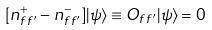<formula> <loc_0><loc_0><loc_500><loc_500>[ { n } ^ { + } _ { f \, f ^ { \prime } } - { n } ^ { - } _ { f \, f ^ { \prime } } ] | \psi \rangle \equiv O _ { f \, f ^ { \prime } } | \psi \rangle = 0</formula> 